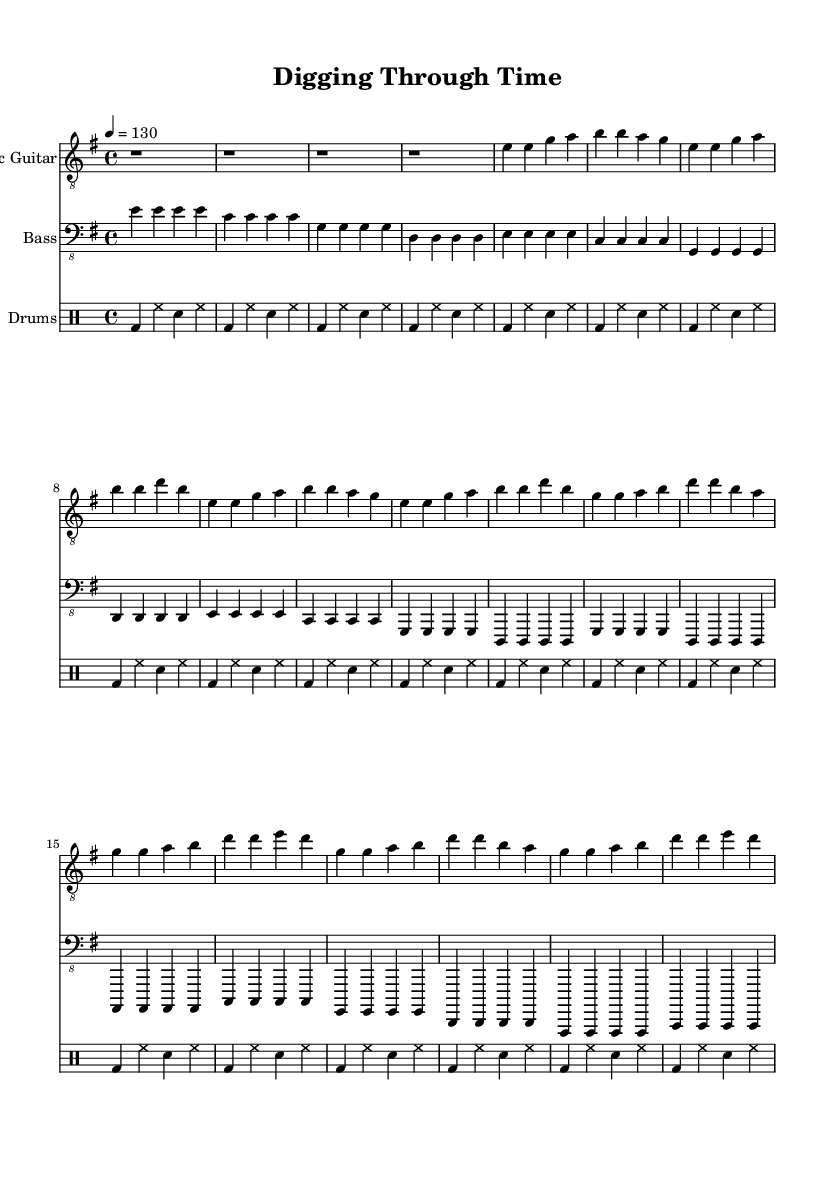What is the key signature of this music? The key signature is indicated at the beginning of the score, showing one sharp, which corresponds to E minor.
Answer: E minor What is the time signature of this music? The time signature is displayed at the start of the piece, indicating that the piece is in 4/4 time, meaning there are four beats per measure.
Answer: 4/4 What is the tempo marking of this music? The tempo marking is provided in the score, showing a quarter note equals 130 beats per minute, which indicates a moderate to fast pace for the music.
Answer: 130 How many measures are in the chorus section? By counting the measures from the score in the chorus section, we find it consists of 8 measures, as indicated by the repeated patterns.
Answer: 8 What is the overall dynamic style of the score? The sheet music does not specify dynamic markings directly, but the hard rock genre typically favors a loud and aggressive performance style. Thus, it can be concluded that the overall dynamic is loud.
Answer: Loud What instruments are featured in this music? The score lists three instruments: Electric Guitar, Bass, and Drums, and these are identified at the beginning of each staff line.
Answer: Electric Guitar, Bass, Drums Does this piece utilize any specific rock characteristics? The use of electric guitar riffs, a steady bass groove, and a driving drum beat signifies typical rock characteristics present in this piece.
Answer: Yes 